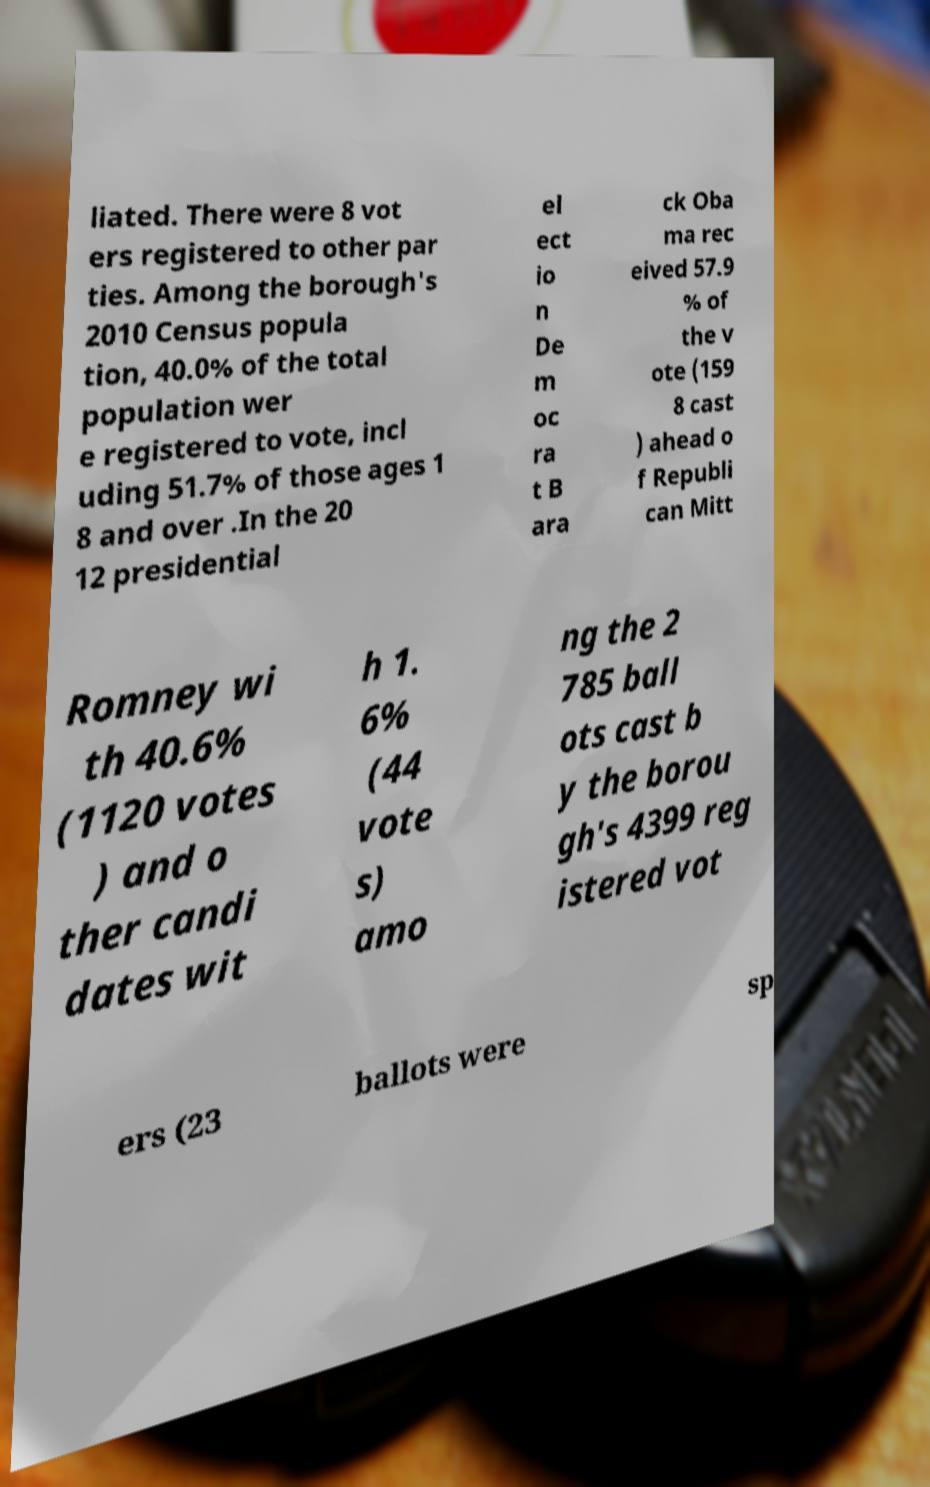For documentation purposes, I need the text within this image transcribed. Could you provide that? liated. There were 8 vot ers registered to other par ties. Among the borough's 2010 Census popula tion, 40.0% of the total population wer e registered to vote, incl uding 51.7% of those ages 1 8 and over .In the 20 12 presidential el ect io n De m oc ra t B ara ck Oba ma rec eived 57.9 % of the v ote (159 8 cast ) ahead o f Republi can Mitt Romney wi th 40.6% (1120 votes ) and o ther candi dates wit h 1. 6% (44 vote s) amo ng the 2 785 ball ots cast b y the borou gh's 4399 reg istered vot ers (23 ballots were sp 